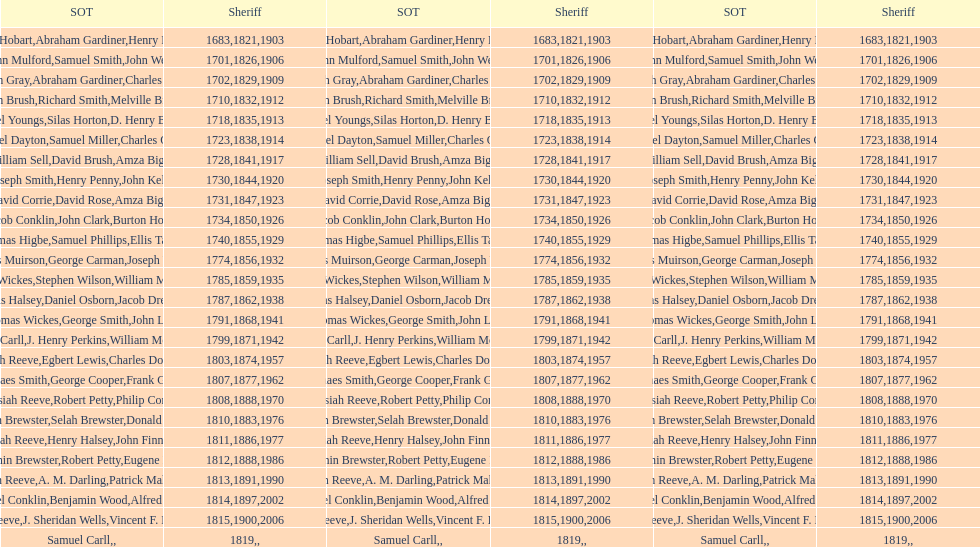When did benjamin brewster serve his second term? 1812. Could you parse the entire table as a dict? {'header': ['SOT', 'Sheriff', 'SOT', 'Sheriff', 'SOT', 'Sheriff'], 'rows': [['Josiah Hobart', '1683', 'Abraham Gardiner', '1821', 'Henry Preston', '1903'], ['John Mulford', '1701', 'Samuel Smith', '1826', 'John Wells', '1906'], ['Hugh Gray', '1702', 'Abraham Gardiner', '1829', 'Charles Platt', '1909'], ['John Brush', '1710', 'Richard Smith', '1832', 'Melville Brush', '1912'], ['Daniel Youngs', '1718', 'Silas Horton', '1835', 'D. Henry Brown', '1913'], ['Samuel Dayton', '1723', 'Samuel Miller', '1838', "Charles O'Dell", '1914'], ['William Sell', '1728', 'David Brush', '1841', 'Amza Biggs', '1917'], ['Joseph Smith', '1730', 'Henry Penny', '1844', 'John Kelly', '1920'], ['David Corrie', '1731', 'David Rose', '1847', 'Amza Biggs', '1923'], ['Jacob Conklin', '1734', 'John Clark', '1850', 'Burton Howe', '1926'], ['Thomas Higbe', '1740', 'Samuel Phillips', '1855', 'Ellis Taylor', '1929'], ['James Muirson', '1774', 'George Carman', '1856', 'Joseph Warta', '1932'], ['Thomas Wickes', '1785', 'Stephen Wilson', '1859', 'William McCollom', '1935'], ['Silas Halsey', '1787', 'Daniel Osborn', '1862', 'Jacob Dreyer', '1938'], ['Thomas Wickes', '1791', 'George Smith', '1868', 'John Levy', '1941'], ['Phinaes Carll', '1799', 'J. Henry Perkins', '1871', 'William McCollom', '1942'], ['Josiah Reeve', '1803', 'Egbert Lewis', '1874', 'Charles Dominy', '1957'], ['Phinaes Smith', '1807', 'George Cooper', '1877', 'Frank Gross', '1962'], ['Josiah Reeve', '1808', 'Robert Petty', '1888', 'Philip Corso', '1970'], ['Benjamin Brewster', '1810', 'Selah Brewster', '1883', 'Donald Dilworth', '1976'], ['Josiah Reeve', '1811', 'Henry Halsey', '1886', 'John Finnerty', '1977'], ['Benjamin Brewster', '1812', 'Robert Petty', '1888', 'Eugene Dooley', '1986'], ['Josiah Reeve', '1813', 'A. M. Darling', '1891', 'Patrick Mahoney', '1990'], ['Nathaniel Conklin', '1814', 'Benjamin Wood', '1897', 'Alfred C. Tisch', '2002'], ['Josiah Reeve', '1815', 'J. Sheridan Wells', '1900', 'Vincent F. DeMarco', '2006'], ['Samuel Carll', '1819', '', '', '', '']]} 